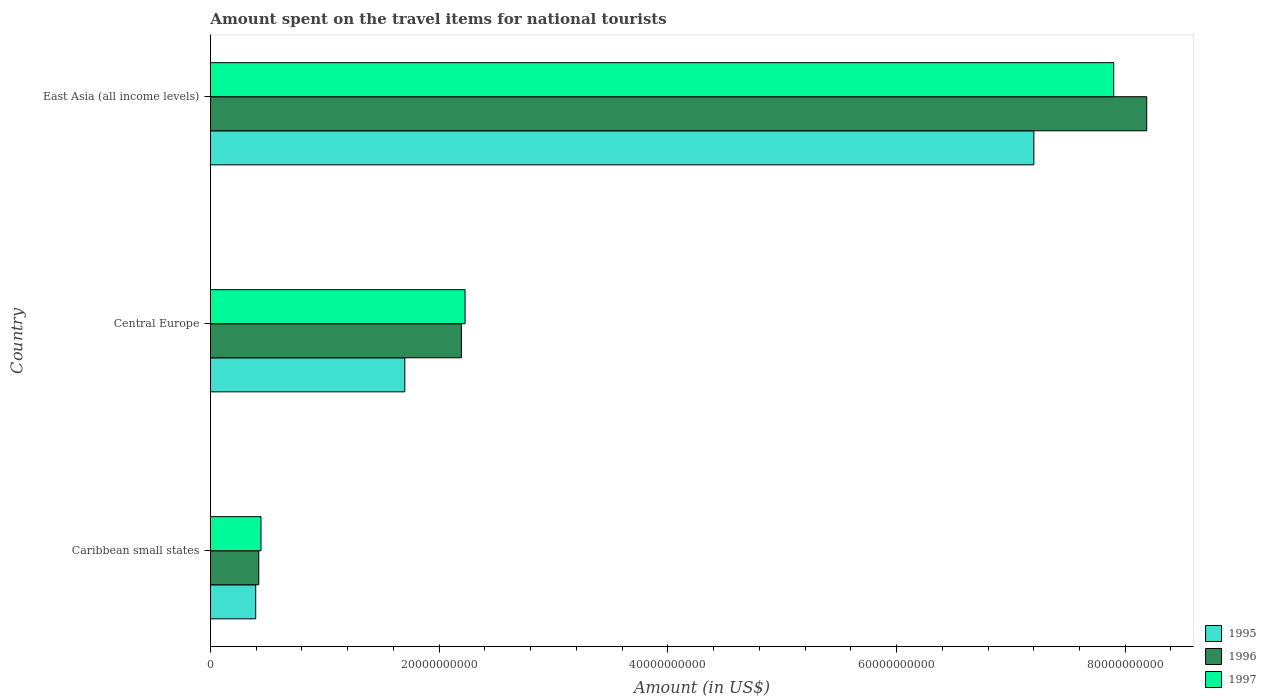Are the number of bars on each tick of the Y-axis equal?
Make the answer very short. Yes. How many bars are there on the 1st tick from the top?
Give a very brief answer. 3. How many bars are there on the 3rd tick from the bottom?
Provide a short and direct response. 3. What is the label of the 3rd group of bars from the top?
Provide a short and direct response. Caribbean small states. In how many cases, is the number of bars for a given country not equal to the number of legend labels?
Make the answer very short. 0. What is the amount spent on the travel items for national tourists in 1995 in Caribbean small states?
Provide a short and direct response. 3.96e+09. Across all countries, what is the maximum amount spent on the travel items for national tourists in 1995?
Make the answer very short. 7.20e+1. Across all countries, what is the minimum amount spent on the travel items for national tourists in 1996?
Your answer should be compact. 4.22e+09. In which country was the amount spent on the travel items for national tourists in 1997 maximum?
Provide a succinct answer. East Asia (all income levels). In which country was the amount spent on the travel items for national tourists in 1996 minimum?
Your answer should be compact. Caribbean small states. What is the total amount spent on the travel items for national tourists in 1995 in the graph?
Make the answer very short. 9.30e+1. What is the difference between the amount spent on the travel items for national tourists in 1995 in Caribbean small states and that in Central Europe?
Keep it short and to the point. -1.30e+1. What is the difference between the amount spent on the travel items for national tourists in 1997 in Caribbean small states and the amount spent on the travel items for national tourists in 1996 in Central Europe?
Provide a succinct answer. -1.75e+1. What is the average amount spent on the travel items for national tourists in 1997 per country?
Offer a very short reply. 3.52e+1. What is the difference between the amount spent on the travel items for national tourists in 1997 and amount spent on the travel items for national tourists in 1996 in Central Europe?
Ensure brevity in your answer.  3.21e+08. In how many countries, is the amount spent on the travel items for national tourists in 1996 greater than 60000000000 US$?
Offer a very short reply. 1. What is the ratio of the amount spent on the travel items for national tourists in 1997 in Caribbean small states to that in East Asia (all income levels)?
Your answer should be very brief. 0.06. Is the amount spent on the travel items for national tourists in 1996 in Caribbean small states less than that in Central Europe?
Offer a very short reply. Yes. Is the difference between the amount spent on the travel items for national tourists in 1997 in Central Europe and East Asia (all income levels) greater than the difference between the amount spent on the travel items for national tourists in 1996 in Central Europe and East Asia (all income levels)?
Provide a succinct answer. Yes. What is the difference between the highest and the second highest amount spent on the travel items for national tourists in 1995?
Give a very brief answer. 5.50e+1. What is the difference between the highest and the lowest amount spent on the travel items for national tourists in 1995?
Offer a terse response. 6.81e+1. How many bars are there?
Ensure brevity in your answer.  9. What is the difference between two consecutive major ticks on the X-axis?
Provide a succinct answer. 2.00e+1. Where does the legend appear in the graph?
Provide a succinct answer. Bottom right. How are the legend labels stacked?
Provide a short and direct response. Vertical. What is the title of the graph?
Give a very brief answer. Amount spent on the travel items for national tourists. What is the label or title of the Y-axis?
Offer a terse response. Country. What is the Amount (in US$) in 1995 in Caribbean small states?
Keep it short and to the point. 3.96e+09. What is the Amount (in US$) of 1996 in Caribbean small states?
Offer a terse response. 4.22e+09. What is the Amount (in US$) in 1997 in Caribbean small states?
Provide a succinct answer. 4.42e+09. What is the Amount (in US$) in 1995 in Central Europe?
Your answer should be very brief. 1.70e+1. What is the Amount (in US$) of 1996 in Central Europe?
Your response must be concise. 2.19e+1. What is the Amount (in US$) of 1997 in Central Europe?
Your response must be concise. 2.23e+1. What is the Amount (in US$) in 1995 in East Asia (all income levels)?
Offer a terse response. 7.20e+1. What is the Amount (in US$) in 1996 in East Asia (all income levels)?
Your response must be concise. 8.19e+1. What is the Amount (in US$) of 1997 in East Asia (all income levels)?
Ensure brevity in your answer.  7.90e+1. Across all countries, what is the maximum Amount (in US$) of 1995?
Offer a very short reply. 7.20e+1. Across all countries, what is the maximum Amount (in US$) in 1996?
Offer a very short reply. 8.19e+1. Across all countries, what is the maximum Amount (in US$) of 1997?
Your answer should be very brief. 7.90e+1. Across all countries, what is the minimum Amount (in US$) of 1995?
Offer a very short reply. 3.96e+09. Across all countries, what is the minimum Amount (in US$) in 1996?
Make the answer very short. 4.22e+09. Across all countries, what is the minimum Amount (in US$) in 1997?
Ensure brevity in your answer.  4.42e+09. What is the total Amount (in US$) in 1995 in the graph?
Offer a very short reply. 9.30e+1. What is the total Amount (in US$) in 1996 in the graph?
Ensure brevity in your answer.  1.08e+11. What is the total Amount (in US$) of 1997 in the graph?
Your response must be concise. 1.06e+11. What is the difference between the Amount (in US$) of 1995 in Caribbean small states and that in Central Europe?
Provide a succinct answer. -1.30e+1. What is the difference between the Amount (in US$) in 1996 in Caribbean small states and that in Central Europe?
Ensure brevity in your answer.  -1.77e+1. What is the difference between the Amount (in US$) in 1997 in Caribbean small states and that in Central Europe?
Give a very brief answer. -1.78e+1. What is the difference between the Amount (in US$) in 1995 in Caribbean small states and that in East Asia (all income levels)?
Keep it short and to the point. -6.81e+1. What is the difference between the Amount (in US$) of 1996 in Caribbean small states and that in East Asia (all income levels)?
Your answer should be very brief. -7.77e+1. What is the difference between the Amount (in US$) of 1997 in Caribbean small states and that in East Asia (all income levels)?
Give a very brief answer. -7.46e+1. What is the difference between the Amount (in US$) of 1995 in Central Europe and that in East Asia (all income levels)?
Offer a terse response. -5.50e+1. What is the difference between the Amount (in US$) of 1996 in Central Europe and that in East Asia (all income levels)?
Your response must be concise. -5.99e+1. What is the difference between the Amount (in US$) in 1997 in Central Europe and that in East Asia (all income levels)?
Give a very brief answer. -5.67e+1. What is the difference between the Amount (in US$) in 1995 in Caribbean small states and the Amount (in US$) in 1996 in Central Europe?
Give a very brief answer. -1.80e+1. What is the difference between the Amount (in US$) in 1995 in Caribbean small states and the Amount (in US$) in 1997 in Central Europe?
Keep it short and to the point. -1.83e+1. What is the difference between the Amount (in US$) of 1996 in Caribbean small states and the Amount (in US$) of 1997 in Central Europe?
Ensure brevity in your answer.  -1.80e+1. What is the difference between the Amount (in US$) of 1995 in Caribbean small states and the Amount (in US$) of 1996 in East Asia (all income levels)?
Keep it short and to the point. -7.79e+1. What is the difference between the Amount (in US$) of 1995 in Caribbean small states and the Amount (in US$) of 1997 in East Asia (all income levels)?
Make the answer very short. -7.50e+1. What is the difference between the Amount (in US$) of 1996 in Caribbean small states and the Amount (in US$) of 1997 in East Asia (all income levels)?
Provide a short and direct response. -7.48e+1. What is the difference between the Amount (in US$) of 1995 in Central Europe and the Amount (in US$) of 1996 in East Asia (all income levels)?
Make the answer very short. -6.49e+1. What is the difference between the Amount (in US$) of 1995 in Central Europe and the Amount (in US$) of 1997 in East Asia (all income levels)?
Your answer should be compact. -6.20e+1. What is the difference between the Amount (in US$) in 1996 in Central Europe and the Amount (in US$) in 1997 in East Asia (all income levels)?
Provide a succinct answer. -5.71e+1. What is the average Amount (in US$) in 1995 per country?
Make the answer very short. 3.10e+1. What is the average Amount (in US$) of 1996 per country?
Ensure brevity in your answer.  3.60e+1. What is the average Amount (in US$) of 1997 per country?
Provide a succinct answer. 3.52e+1. What is the difference between the Amount (in US$) in 1995 and Amount (in US$) in 1996 in Caribbean small states?
Offer a terse response. -2.66e+08. What is the difference between the Amount (in US$) of 1995 and Amount (in US$) of 1997 in Caribbean small states?
Offer a terse response. -4.62e+08. What is the difference between the Amount (in US$) in 1996 and Amount (in US$) in 1997 in Caribbean small states?
Provide a short and direct response. -1.96e+08. What is the difference between the Amount (in US$) in 1995 and Amount (in US$) in 1996 in Central Europe?
Give a very brief answer. -4.95e+09. What is the difference between the Amount (in US$) of 1995 and Amount (in US$) of 1997 in Central Europe?
Provide a succinct answer. -5.27e+09. What is the difference between the Amount (in US$) in 1996 and Amount (in US$) in 1997 in Central Europe?
Provide a short and direct response. -3.21e+08. What is the difference between the Amount (in US$) of 1995 and Amount (in US$) of 1996 in East Asia (all income levels)?
Provide a succinct answer. -9.87e+09. What is the difference between the Amount (in US$) in 1995 and Amount (in US$) in 1997 in East Asia (all income levels)?
Offer a terse response. -6.98e+09. What is the difference between the Amount (in US$) of 1996 and Amount (in US$) of 1997 in East Asia (all income levels)?
Ensure brevity in your answer.  2.89e+09. What is the ratio of the Amount (in US$) in 1995 in Caribbean small states to that in Central Europe?
Provide a short and direct response. 0.23. What is the ratio of the Amount (in US$) of 1996 in Caribbean small states to that in Central Europe?
Make the answer very short. 0.19. What is the ratio of the Amount (in US$) of 1997 in Caribbean small states to that in Central Europe?
Your answer should be compact. 0.2. What is the ratio of the Amount (in US$) of 1995 in Caribbean small states to that in East Asia (all income levels)?
Ensure brevity in your answer.  0.05. What is the ratio of the Amount (in US$) in 1996 in Caribbean small states to that in East Asia (all income levels)?
Keep it short and to the point. 0.05. What is the ratio of the Amount (in US$) in 1997 in Caribbean small states to that in East Asia (all income levels)?
Your answer should be compact. 0.06. What is the ratio of the Amount (in US$) of 1995 in Central Europe to that in East Asia (all income levels)?
Your answer should be compact. 0.24. What is the ratio of the Amount (in US$) in 1996 in Central Europe to that in East Asia (all income levels)?
Your response must be concise. 0.27. What is the ratio of the Amount (in US$) of 1997 in Central Europe to that in East Asia (all income levels)?
Provide a succinct answer. 0.28. What is the difference between the highest and the second highest Amount (in US$) of 1995?
Give a very brief answer. 5.50e+1. What is the difference between the highest and the second highest Amount (in US$) of 1996?
Offer a very short reply. 5.99e+1. What is the difference between the highest and the second highest Amount (in US$) in 1997?
Your response must be concise. 5.67e+1. What is the difference between the highest and the lowest Amount (in US$) of 1995?
Give a very brief answer. 6.81e+1. What is the difference between the highest and the lowest Amount (in US$) of 1996?
Make the answer very short. 7.77e+1. What is the difference between the highest and the lowest Amount (in US$) of 1997?
Provide a short and direct response. 7.46e+1. 